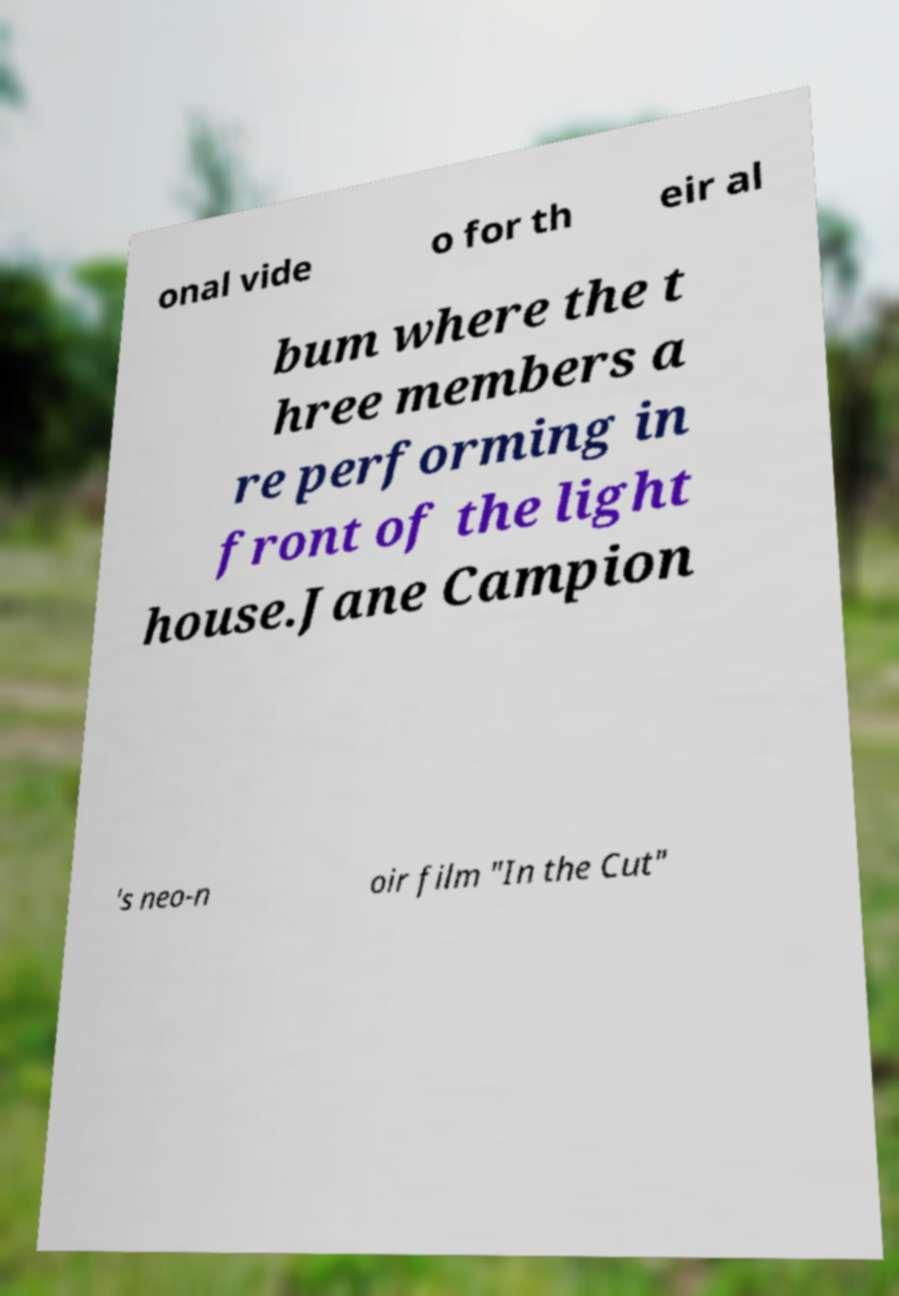Please read and relay the text visible in this image. What does it say? onal vide o for th eir al bum where the t hree members a re performing in front of the light house.Jane Campion 's neo-n oir film "In the Cut" 